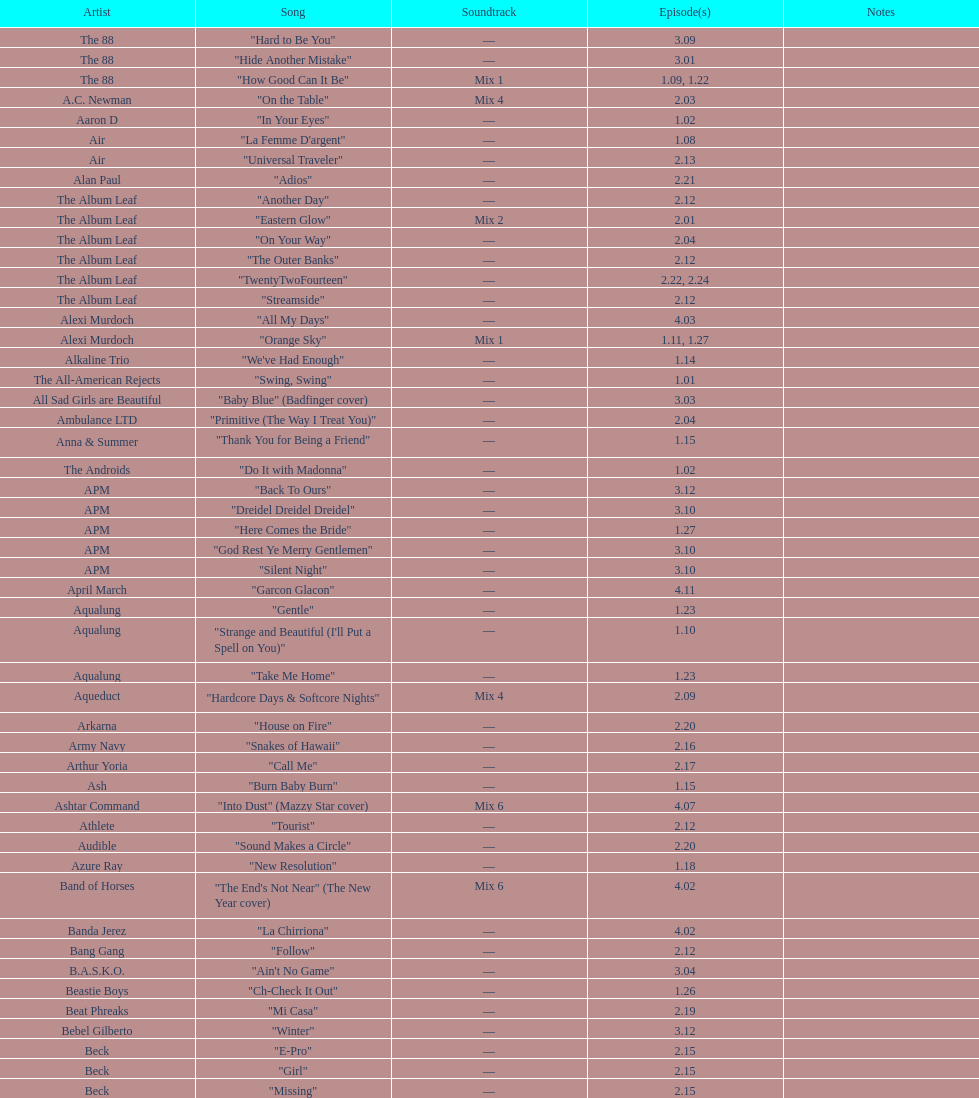How many episodes have a rating under 27. 